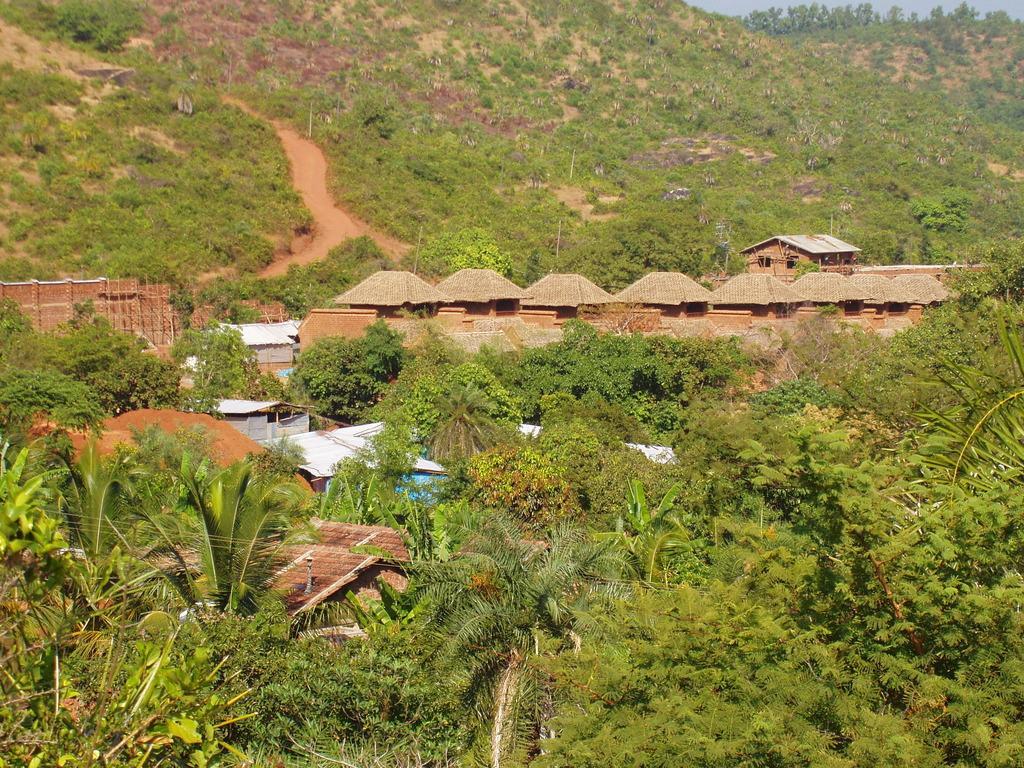In one or two sentences, can you explain what this image depicts? In this image we can see some houses, plants, trees, also we can see the sky. 